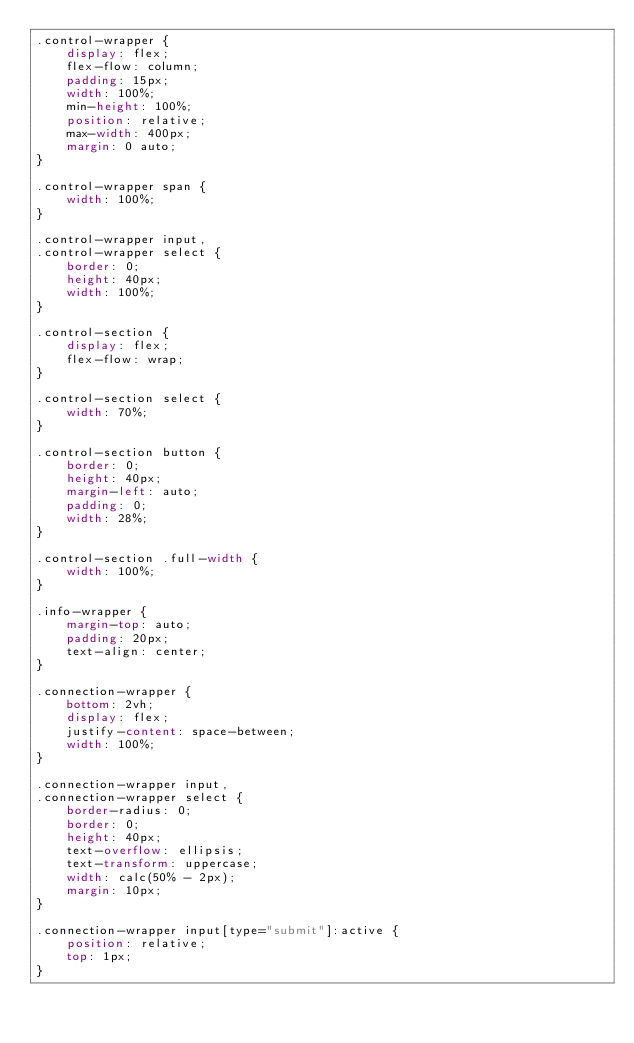Convert code to text. <code><loc_0><loc_0><loc_500><loc_500><_CSS_>.control-wrapper {
    display: flex;
    flex-flow: column;
    padding: 15px;
    width: 100%;
    min-height: 100%;
    position: relative;
    max-width: 400px;
    margin: 0 auto;
}

.control-wrapper span {
    width: 100%;
}

.control-wrapper input,
.control-wrapper select {
    border: 0;
    height: 40px;
    width: 100%;
}

.control-section {
    display: flex;
    flex-flow: wrap;
}

.control-section select {
    width: 70%;
}

.control-section button {
    border: 0;
    height: 40px;
    margin-left: auto;
    padding: 0;
    width: 28%;
}

.control-section .full-width {
    width: 100%;
}

.info-wrapper {
    margin-top: auto;
    padding: 20px;
    text-align: center;
}

.connection-wrapper {
    bottom: 2vh;
    display: flex;
    justify-content: space-between;
    width: 100%;
}

.connection-wrapper input,
.connection-wrapper select {
    border-radius: 0;
    border: 0;
    height: 40px;
    text-overflow: ellipsis;
    text-transform: uppercase;
    width: calc(50% - 2px);
    margin: 10px;
}

.connection-wrapper input[type="submit"]:active {
    position: relative;
    top: 1px;
}
</code> 